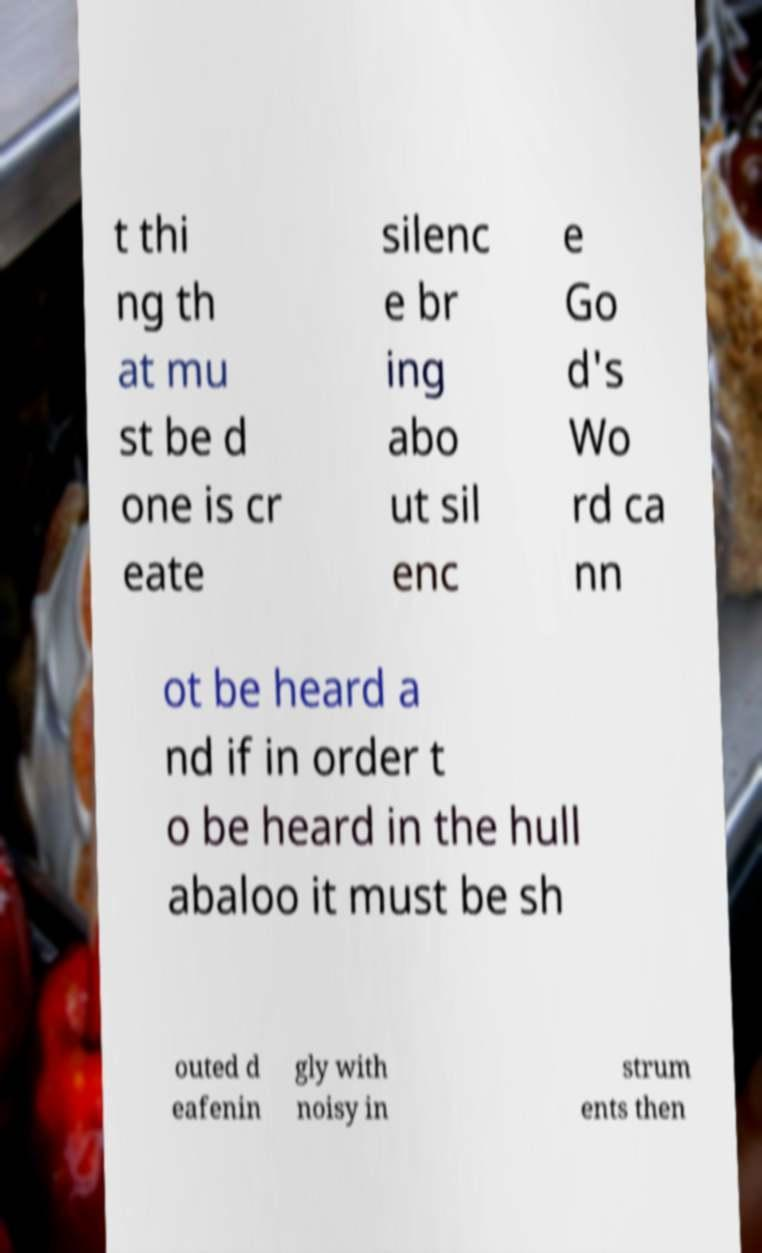Can you read and provide the text displayed in the image?This photo seems to have some interesting text. Can you extract and type it out for me? t thi ng th at mu st be d one is cr eate silenc e br ing abo ut sil enc e Go d's Wo rd ca nn ot be heard a nd if in order t o be heard in the hull abaloo it must be sh outed d eafenin gly with noisy in strum ents then 